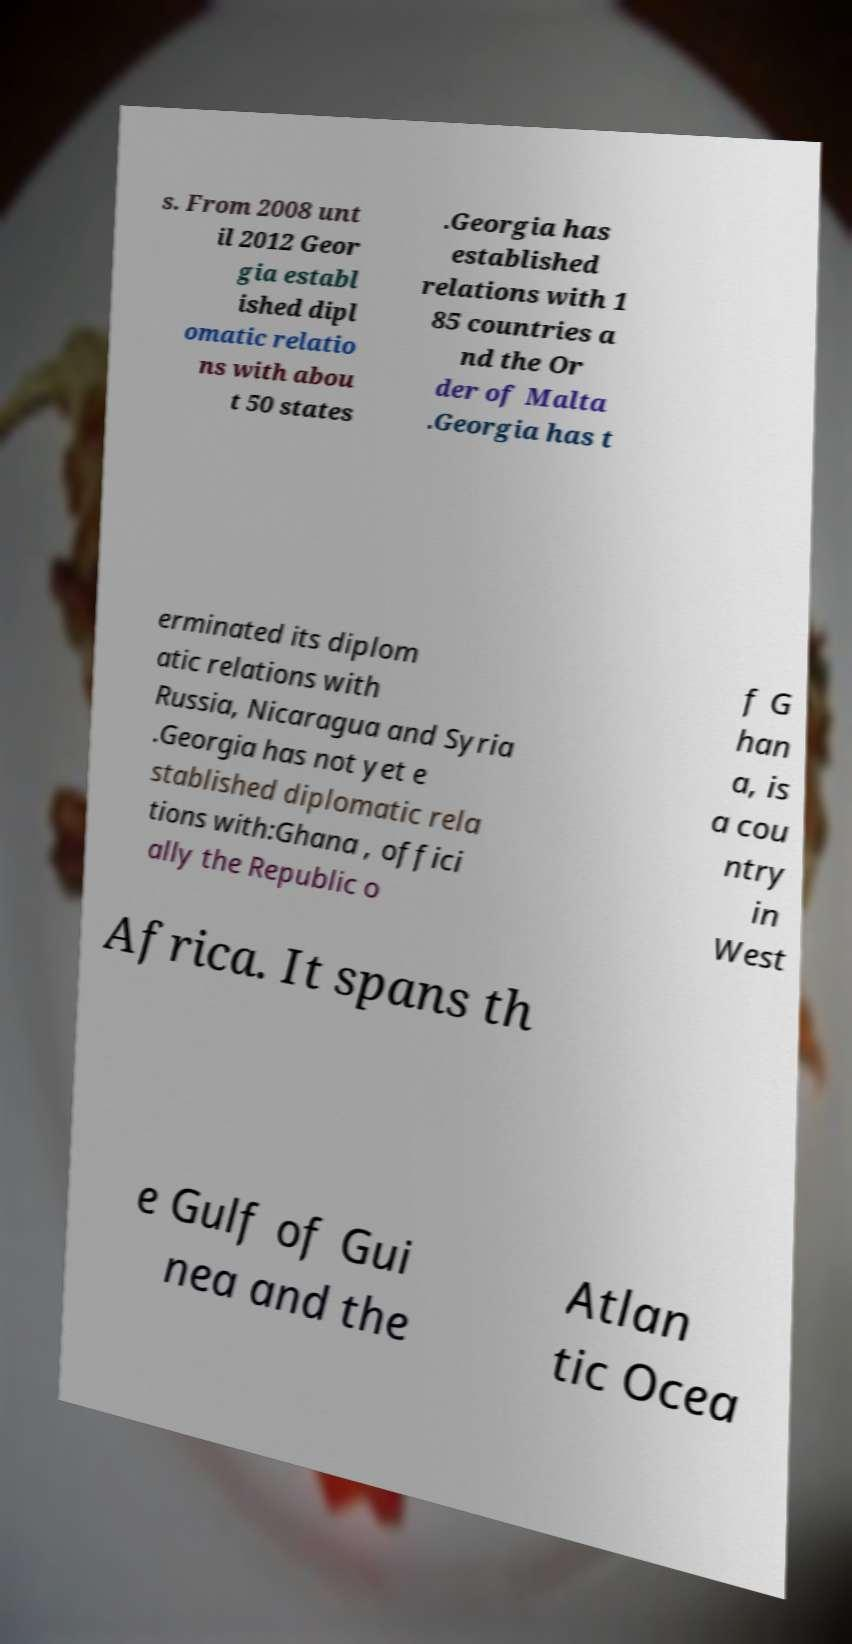Could you extract and type out the text from this image? s. From 2008 unt il 2012 Geor gia establ ished dipl omatic relatio ns with abou t 50 states .Georgia has established relations with 1 85 countries a nd the Or der of Malta .Georgia has t erminated its diplom atic relations with Russia, Nicaragua and Syria .Georgia has not yet e stablished diplomatic rela tions with:Ghana , offici ally the Republic o f G han a, is a cou ntry in West Africa. It spans th e Gulf of Gui nea and the Atlan tic Ocea 